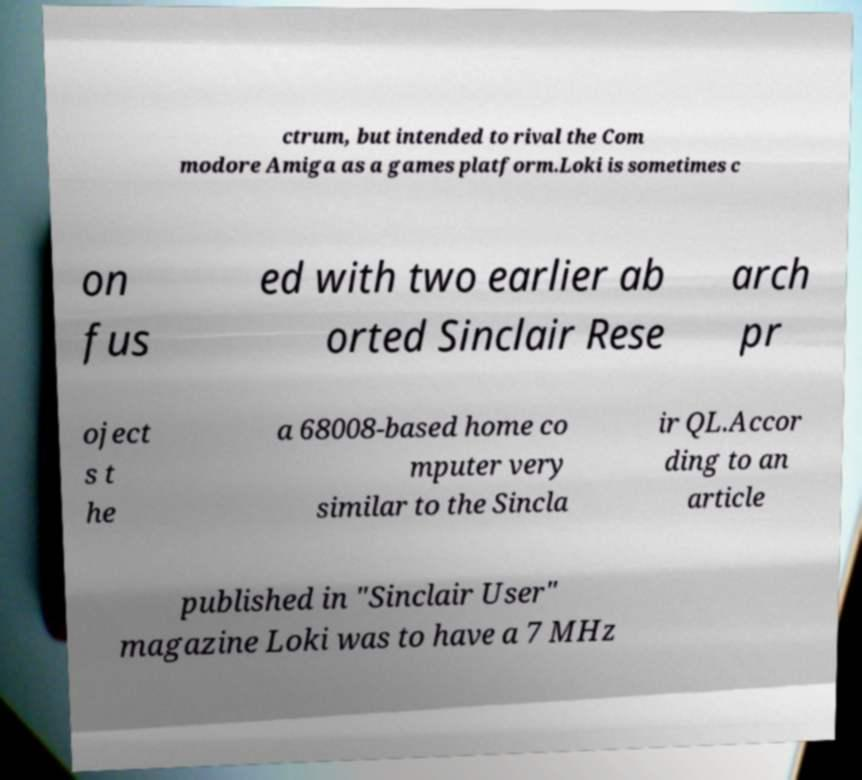Can you accurately transcribe the text from the provided image for me? ctrum, but intended to rival the Com modore Amiga as a games platform.Loki is sometimes c on fus ed with two earlier ab orted Sinclair Rese arch pr oject s t he a 68008-based home co mputer very similar to the Sincla ir QL.Accor ding to an article published in "Sinclair User" magazine Loki was to have a 7 MHz 